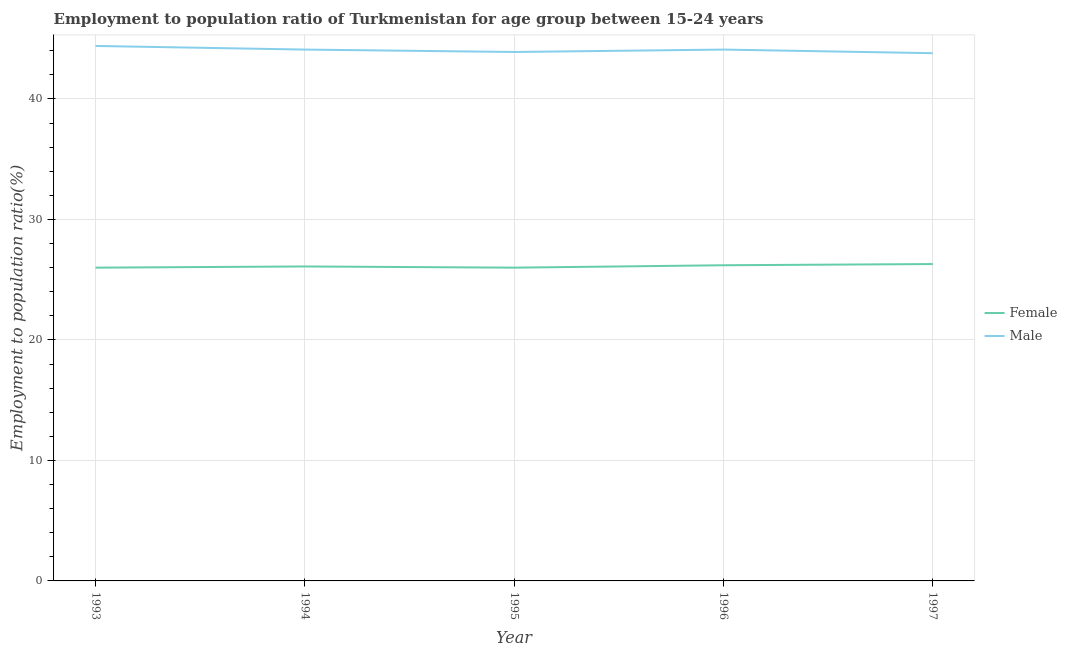Does the line corresponding to employment to population ratio(male) intersect with the line corresponding to employment to population ratio(female)?
Ensure brevity in your answer.  No. What is the employment to population ratio(male) in 1995?
Provide a short and direct response. 43.9. Across all years, what is the maximum employment to population ratio(male)?
Make the answer very short. 44.4. Across all years, what is the minimum employment to population ratio(female)?
Your response must be concise. 26. In which year was the employment to population ratio(female) minimum?
Offer a very short reply. 1993. What is the total employment to population ratio(female) in the graph?
Provide a succinct answer. 130.6. What is the difference between the employment to population ratio(male) in 1994 and that in 1996?
Give a very brief answer. 0. What is the difference between the employment to population ratio(male) in 1994 and the employment to population ratio(female) in 1997?
Your answer should be very brief. 17.8. What is the average employment to population ratio(female) per year?
Give a very brief answer. 26.12. In the year 1997, what is the difference between the employment to population ratio(female) and employment to population ratio(male)?
Your response must be concise. -17.5. In how many years, is the employment to population ratio(female) greater than 34 %?
Offer a very short reply. 0. What is the ratio of the employment to population ratio(male) in 1993 to that in 1997?
Your answer should be very brief. 1.01. What is the difference between the highest and the second highest employment to population ratio(male)?
Your response must be concise. 0.3. What is the difference between the highest and the lowest employment to population ratio(female)?
Keep it short and to the point. 0.3. In how many years, is the employment to population ratio(female) greater than the average employment to population ratio(female) taken over all years?
Make the answer very short. 2. Is the sum of the employment to population ratio(female) in 1993 and 1995 greater than the maximum employment to population ratio(male) across all years?
Provide a short and direct response. Yes. Is the employment to population ratio(female) strictly greater than the employment to population ratio(male) over the years?
Make the answer very short. No. How many years are there in the graph?
Your answer should be very brief. 5. What is the difference between two consecutive major ticks on the Y-axis?
Your answer should be compact. 10. Does the graph contain any zero values?
Offer a terse response. No. Does the graph contain grids?
Your answer should be compact. Yes. How are the legend labels stacked?
Offer a very short reply. Vertical. What is the title of the graph?
Make the answer very short. Employment to population ratio of Turkmenistan for age group between 15-24 years. What is the label or title of the X-axis?
Provide a short and direct response. Year. What is the Employment to population ratio(%) in Female in 1993?
Provide a succinct answer. 26. What is the Employment to population ratio(%) of Male in 1993?
Give a very brief answer. 44.4. What is the Employment to population ratio(%) in Female in 1994?
Keep it short and to the point. 26.1. What is the Employment to population ratio(%) of Male in 1994?
Keep it short and to the point. 44.1. What is the Employment to population ratio(%) of Male in 1995?
Provide a short and direct response. 43.9. What is the Employment to population ratio(%) of Female in 1996?
Make the answer very short. 26.2. What is the Employment to population ratio(%) of Male in 1996?
Ensure brevity in your answer.  44.1. What is the Employment to population ratio(%) of Female in 1997?
Offer a terse response. 26.3. What is the Employment to population ratio(%) in Male in 1997?
Make the answer very short. 43.8. Across all years, what is the maximum Employment to population ratio(%) in Female?
Your answer should be compact. 26.3. Across all years, what is the maximum Employment to population ratio(%) of Male?
Keep it short and to the point. 44.4. Across all years, what is the minimum Employment to population ratio(%) in Female?
Offer a terse response. 26. Across all years, what is the minimum Employment to population ratio(%) of Male?
Ensure brevity in your answer.  43.8. What is the total Employment to population ratio(%) of Female in the graph?
Keep it short and to the point. 130.6. What is the total Employment to population ratio(%) in Male in the graph?
Keep it short and to the point. 220.3. What is the difference between the Employment to population ratio(%) of Female in 1993 and that in 1994?
Your response must be concise. -0.1. What is the difference between the Employment to population ratio(%) in Male in 1993 and that in 1994?
Provide a short and direct response. 0.3. What is the difference between the Employment to population ratio(%) in Male in 1993 and that in 1995?
Your answer should be compact. 0.5. What is the difference between the Employment to population ratio(%) in Female in 1993 and that in 1997?
Provide a succinct answer. -0.3. What is the difference between the Employment to population ratio(%) of Male in 1993 and that in 1997?
Your response must be concise. 0.6. What is the difference between the Employment to population ratio(%) in Female in 1994 and that in 1995?
Provide a succinct answer. 0.1. What is the difference between the Employment to population ratio(%) of Female in 1994 and that in 1996?
Provide a succinct answer. -0.1. What is the difference between the Employment to population ratio(%) of Female in 1995 and that in 1996?
Your answer should be very brief. -0.2. What is the difference between the Employment to population ratio(%) in Male in 1995 and that in 1996?
Offer a very short reply. -0.2. What is the difference between the Employment to population ratio(%) of Female in 1996 and that in 1997?
Offer a very short reply. -0.1. What is the difference between the Employment to population ratio(%) of Male in 1996 and that in 1997?
Ensure brevity in your answer.  0.3. What is the difference between the Employment to population ratio(%) in Female in 1993 and the Employment to population ratio(%) in Male in 1994?
Provide a succinct answer. -18.1. What is the difference between the Employment to population ratio(%) of Female in 1993 and the Employment to population ratio(%) of Male in 1995?
Give a very brief answer. -17.9. What is the difference between the Employment to population ratio(%) of Female in 1993 and the Employment to population ratio(%) of Male in 1996?
Your response must be concise. -18.1. What is the difference between the Employment to population ratio(%) of Female in 1993 and the Employment to population ratio(%) of Male in 1997?
Ensure brevity in your answer.  -17.8. What is the difference between the Employment to population ratio(%) of Female in 1994 and the Employment to population ratio(%) of Male in 1995?
Make the answer very short. -17.8. What is the difference between the Employment to population ratio(%) in Female in 1994 and the Employment to population ratio(%) in Male in 1997?
Offer a terse response. -17.7. What is the difference between the Employment to population ratio(%) in Female in 1995 and the Employment to population ratio(%) in Male in 1996?
Offer a terse response. -18.1. What is the difference between the Employment to population ratio(%) in Female in 1995 and the Employment to population ratio(%) in Male in 1997?
Offer a terse response. -17.8. What is the difference between the Employment to population ratio(%) in Female in 1996 and the Employment to population ratio(%) in Male in 1997?
Your response must be concise. -17.6. What is the average Employment to population ratio(%) of Female per year?
Ensure brevity in your answer.  26.12. What is the average Employment to population ratio(%) of Male per year?
Offer a very short reply. 44.06. In the year 1993, what is the difference between the Employment to population ratio(%) of Female and Employment to population ratio(%) of Male?
Keep it short and to the point. -18.4. In the year 1995, what is the difference between the Employment to population ratio(%) in Female and Employment to population ratio(%) in Male?
Ensure brevity in your answer.  -17.9. In the year 1996, what is the difference between the Employment to population ratio(%) in Female and Employment to population ratio(%) in Male?
Your answer should be very brief. -17.9. In the year 1997, what is the difference between the Employment to population ratio(%) of Female and Employment to population ratio(%) of Male?
Your answer should be compact. -17.5. What is the ratio of the Employment to population ratio(%) of Female in 1993 to that in 1994?
Provide a short and direct response. 1. What is the ratio of the Employment to population ratio(%) in Male in 1993 to that in 1994?
Your response must be concise. 1.01. What is the ratio of the Employment to population ratio(%) in Female in 1993 to that in 1995?
Ensure brevity in your answer.  1. What is the ratio of the Employment to population ratio(%) of Male in 1993 to that in 1995?
Your answer should be very brief. 1.01. What is the ratio of the Employment to population ratio(%) of Male in 1993 to that in 1996?
Your response must be concise. 1.01. What is the ratio of the Employment to population ratio(%) in Female in 1993 to that in 1997?
Provide a succinct answer. 0.99. What is the ratio of the Employment to population ratio(%) in Male in 1993 to that in 1997?
Keep it short and to the point. 1.01. What is the ratio of the Employment to population ratio(%) of Female in 1994 to that in 1996?
Offer a terse response. 1. What is the ratio of the Employment to population ratio(%) in Male in 1994 to that in 1996?
Make the answer very short. 1. What is the ratio of the Employment to population ratio(%) in Female in 1994 to that in 1997?
Offer a terse response. 0.99. What is the ratio of the Employment to population ratio(%) in Male in 1994 to that in 1997?
Provide a short and direct response. 1.01. What is the ratio of the Employment to population ratio(%) of Male in 1995 to that in 1996?
Make the answer very short. 1. What is the ratio of the Employment to population ratio(%) in Female in 1995 to that in 1997?
Give a very brief answer. 0.99. What is the ratio of the Employment to population ratio(%) in Male in 1996 to that in 1997?
Ensure brevity in your answer.  1.01. What is the difference between the highest and the second highest Employment to population ratio(%) of Female?
Offer a very short reply. 0.1. What is the difference between the highest and the lowest Employment to population ratio(%) in Female?
Your answer should be very brief. 0.3. 